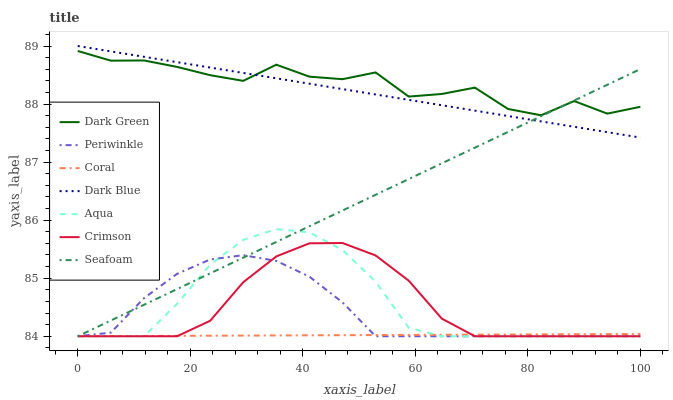Does Coral have the minimum area under the curve?
Answer yes or no. Yes. Does Dark Green have the maximum area under the curve?
Answer yes or no. Yes. Does Aqua have the minimum area under the curve?
Answer yes or no. No. Does Aqua have the maximum area under the curve?
Answer yes or no. No. Is Dark Blue the smoothest?
Answer yes or no. Yes. Is Dark Green the roughest?
Answer yes or no. Yes. Is Aqua the smoothest?
Answer yes or no. No. Is Aqua the roughest?
Answer yes or no. No. Does Coral have the lowest value?
Answer yes or no. Yes. Does Dark Blue have the lowest value?
Answer yes or no. No. Does Dark Blue have the highest value?
Answer yes or no. Yes. Does Aqua have the highest value?
Answer yes or no. No. Is Coral less than Dark Green?
Answer yes or no. Yes. Is Dark Blue greater than Periwinkle?
Answer yes or no. Yes. Does Dark Green intersect Dark Blue?
Answer yes or no. Yes. Is Dark Green less than Dark Blue?
Answer yes or no. No. Is Dark Green greater than Dark Blue?
Answer yes or no. No. Does Coral intersect Dark Green?
Answer yes or no. No. 